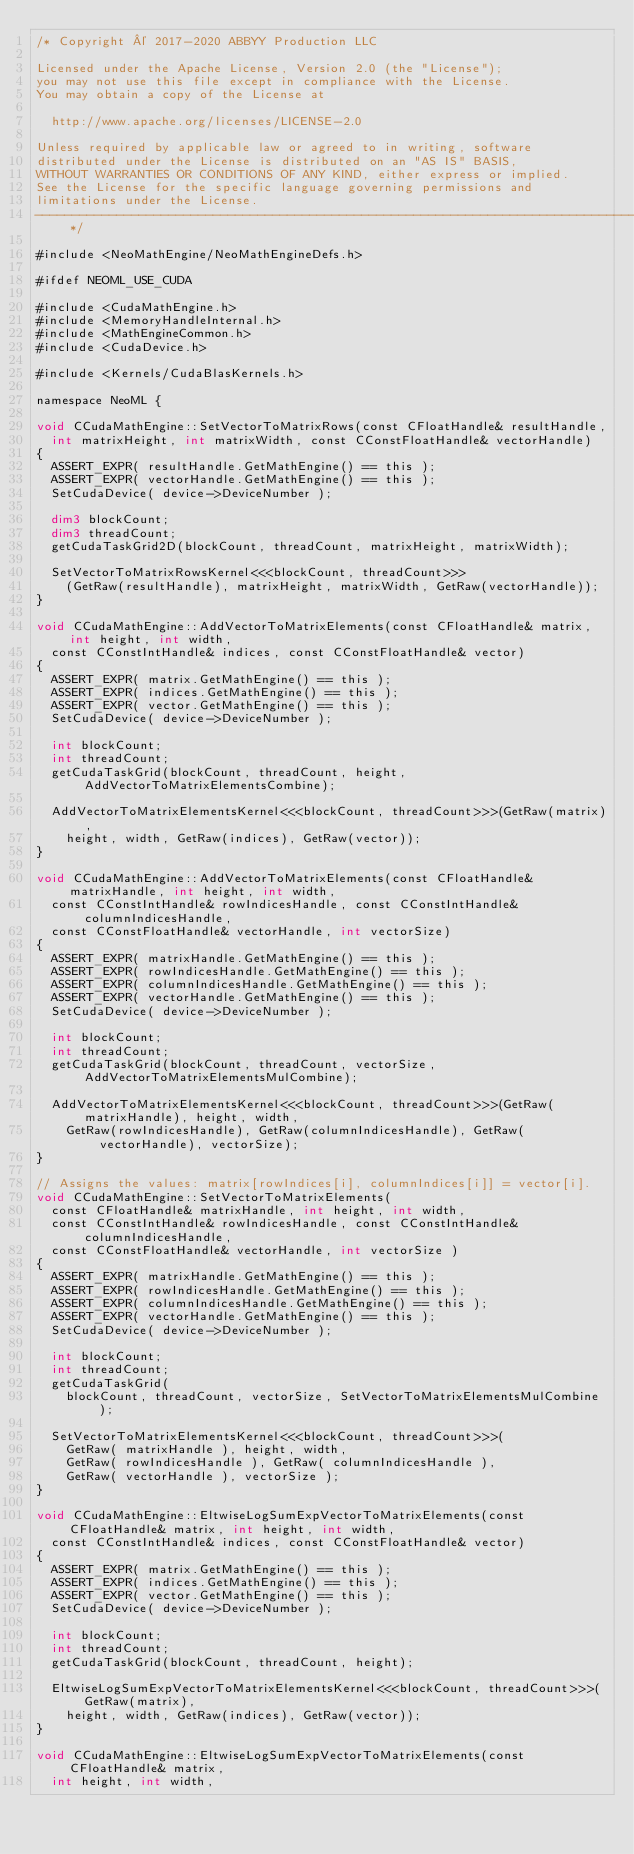<code> <loc_0><loc_0><loc_500><loc_500><_Cuda_>/* Copyright © 2017-2020 ABBYY Production LLC

Licensed under the Apache License, Version 2.0 (the "License");
you may not use this file except in compliance with the License.
You may obtain a copy of the License at

	http://www.apache.org/licenses/LICENSE-2.0

Unless required by applicable law or agreed to in writing, software
distributed under the License is distributed on an "AS IS" BASIS,
WITHOUT WARRANTIES OR CONDITIONS OF ANY KIND, either express or implied.
See the License for the specific language governing permissions and
limitations under the License.
--------------------------------------------------------------------------------------------------------------*/

#include <NeoMathEngine/NeoMathEngineDefs.h>

#ifdef NEOML_USE_CUDA

#include <CudaMathEngine.h>
#include <MemoryHandleInternal.h>
#include <MathEngineCommon.h>
#include <CudaDevice.h>

#include <Kernels/CudaBlasKernels.h>

namespace NeoML {

void CCudaMathEngine::SetVectorToMatrixRows(const CFloatHandle& resultHandle,
	int matrixHeight, int matrixWidth, const CConstFloatHandle& vectorHandle)
{
	ASSERT_EXPR( resultHandle.GetMathEngine() == this );
	ASSERT_EXPR( vectorHandle.GetMathEngine() == this );
	SetCudaDevice( device->DeviceNumber );

	dim3 blockCount;
	dim3 threadCount;
	getCudaTaskGrid2D(blockCount, threadCount, matrixHeight, matrixWidth);

	SetVectorToMatrixRowsKernel<<<blockCount, threadCount>>>
		(GetRaw(resultHandle), matrixHeight, matrixWidth, GetRaw(vectorHandle));
}

void CCudaMathEngine::AddVectorToMatrixElements(const CFloatHandle& matrix, int height, int width,
	const CConstIntHandle& indices, const CConstFloatHandle& vector)
{
	ASSERT_EXPR( matrix.GetMathEngine() == this );
	ASSERT_EXPR( indices.GetMathEngine() == this );
	ASSERT_EXPR( vector.GetMathEngine() == this );
	SetCudaDevice( device->DeviceNumber );

	int blockCount;
	int threadCount;
	getCudaTaskGrid(blockCount, threadCount, height, AddVectorToMatrixElementsCombine);

	AddVectorToMatrixElementsKernel<<<blockCount, threadCount>>>(GetRaw(matrix),
		height, width, GetRaw(indices), GetRaw(vector));
}

void CCudaMathEngine::AddVectorToMatrixElements(const CFloatHandle& matrixHandle, int height, int width,
	const CConstIntHandle& rowIndicesHandle, const CConstIntHandle& columnIndicesHandle,
	const CConstFloatHandle& vectorHandle, int vectorSize)
{
	ASSERT_EXPR( matrixHandle.GetMathEngine() == this );
	ASSERT_EXPR( rowIndicesHandle.GetMathEngine() == this );
	ASSERT_EXPR( columnIndicesHandle.GetMathEngine() == this );
	ASSERT_EXPR( vectorHandle.GetMathEngine() == this );
	SetCudaDevice( device->DeviceNumber );

	int blockCount;
	int threadCount;
	getCudaTaskGrid(blockCount, threadCount, vectorSize, AddVectorToMatrixElementsMulCombine);

	AddVectorToMatrixElementsKernel<<<blockCount, threadCount>>>(GetRaw(matrixHandle), height, width,
		GetRaw(rowIndicesHandle), GetRaw(columnIndicesHandle), GetRaw(vectorHandle), vectorSize);
}

// Assigns the values: matrix[rowIndices[i], columnIndices[i]] = vector[i].
void CCudaMathEngine::SetVectorToMatrixElements(
	const CFloatHandle& matrixHandle, int height, int width,
	const CConstIntHandle& rowIndicesHandle, const CConstIntHandle& columnIndicesHandle,
	const CConstFloatHandle& vectorHandle, int vectorSize )
{
	ASSERT_EXPR( matrixHandle.GetMathEngine() == this );
	ASSERT_EXPR( rowIndicesHandle.GetMathEngine() == this );
	ASSERT_EXPR( columnIndicesHandle.GetMathEngine() == this );
	ASSERT_EXPR( vectorHandle.GetMathEngine() == this );
	SetCudaDevice( device->DeviceNumber );

	int blockCount;
	int threadCount;
	getCudaTaskGrid(
		blockCount, threadCount, vectorSize, SetVectorToMatrixElementsMulCombine );

	SetVectorToMatrixElementsKernel<<<blockCount, threadCount>>>(
		GetRaw( matrixHandle ), height, width,
		GetRaw( rowIndicesHandle ), GetRaw( columnIndicesHandle ),
		GetRaw( vectorHandle ), vectorSize );
}

void CCudaMathEngine::EltwiseLogSumExpVectorToMatrixElements(const CFloatHandle& matrix, int height, int width,
	const CConstIntHandle& indices, const CConstFloatHandle& vector)
{
	ASSERT_EXPR( matrix.GetMathEngine() == this );
	ASSERT_EXPR( indices.GetMathEngine() == this );
	ASSERT_EXPR( vector.GetMathEngine() == this );
	SetCudaDevice( device->DeviceNumber );

	int blockCount;
	int threadCount;
	getCudaTaskGrid(blockCount, threadCount, height);

	EltwiseLogSumExpVectorToMatrixElementsKernel<<<blockCount, threadCount>>>(GetRaw(matrix),
		height, width, GetRaw(indices), GetRaw(vector));
}

void CCudaMathEngine::EltwiseLogSumExpVectorToMatrixElements(const CFloatHandle& matrix,
	int height, int width,</code> 